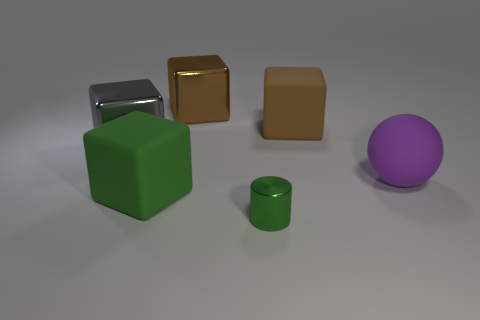Is there any other thing that is the same size as the green metallic cylinder?
Offer a very short reply. No. What shape is the large metallic object that is in front of the large brown metal cube that is behind the brown thing that is right of the big brown metallic block?
Your response must be concise. Cube. What size is the gray shiny block?
Give a very brief answer. Large. Is there a small cyan thing made of the same material as the purple ball?
Give a very brief answer. No. The green object that is the same shape as the gray object is what size?
Provide a succinct answer. Large. Are there the same number of green blocks behind the brown matte block and brown rubber blocks?
Provide a succinct answer. No. Is the shape of the green object in front of the big green rubber cube the same as  the purple thing?
Your response must be concise. No. The big brown shiny thing has what shape?
Your answer should be very brief. Cube. What is the material of the big block in front of the purple sphere that is in front of the rubber object that is behind the large gray metallic object?
Make the answer very short. Rubber. There is a large thing that is the same color as the tiny thing; what is it made of?
Give a very brief answer. Rubber. 